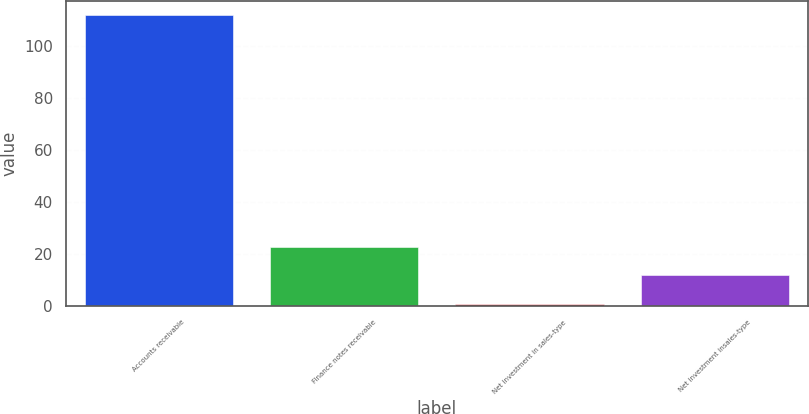<chart> <loc_0><loc_0><loc_500><loc_500><bar_chart><fcel>Accounts receivable<fcel>Finance notes receivable<fcel>Net investment in sales-type<fcel>Net investment insales-type<nl><fcel>111.8<fcel>22.84<fcel>0.6<fcel>11.72<nl></chart> 